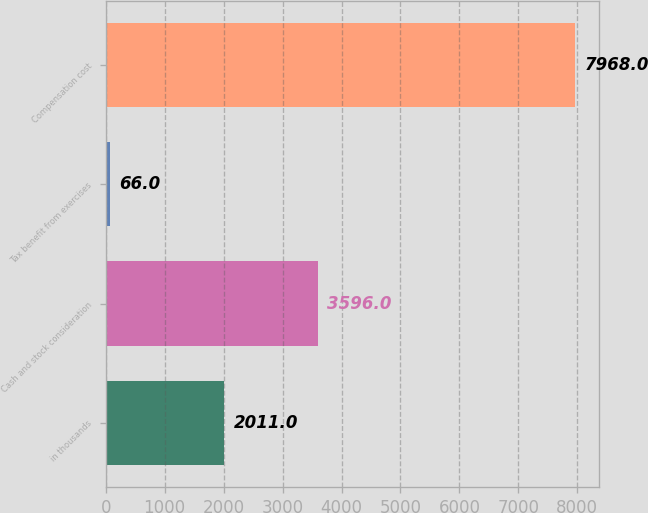<chart> <loc_0><loc_0><loc_500><loc_500><bar_chart><fcel>in thousands<fcel>Cash and stock consideration<fcel>Tax benefit from exercises<fcel>Compensation cost<nl><fcel>2011<fcel>3596<fcel>66<fcel>7968<nl></chart> 